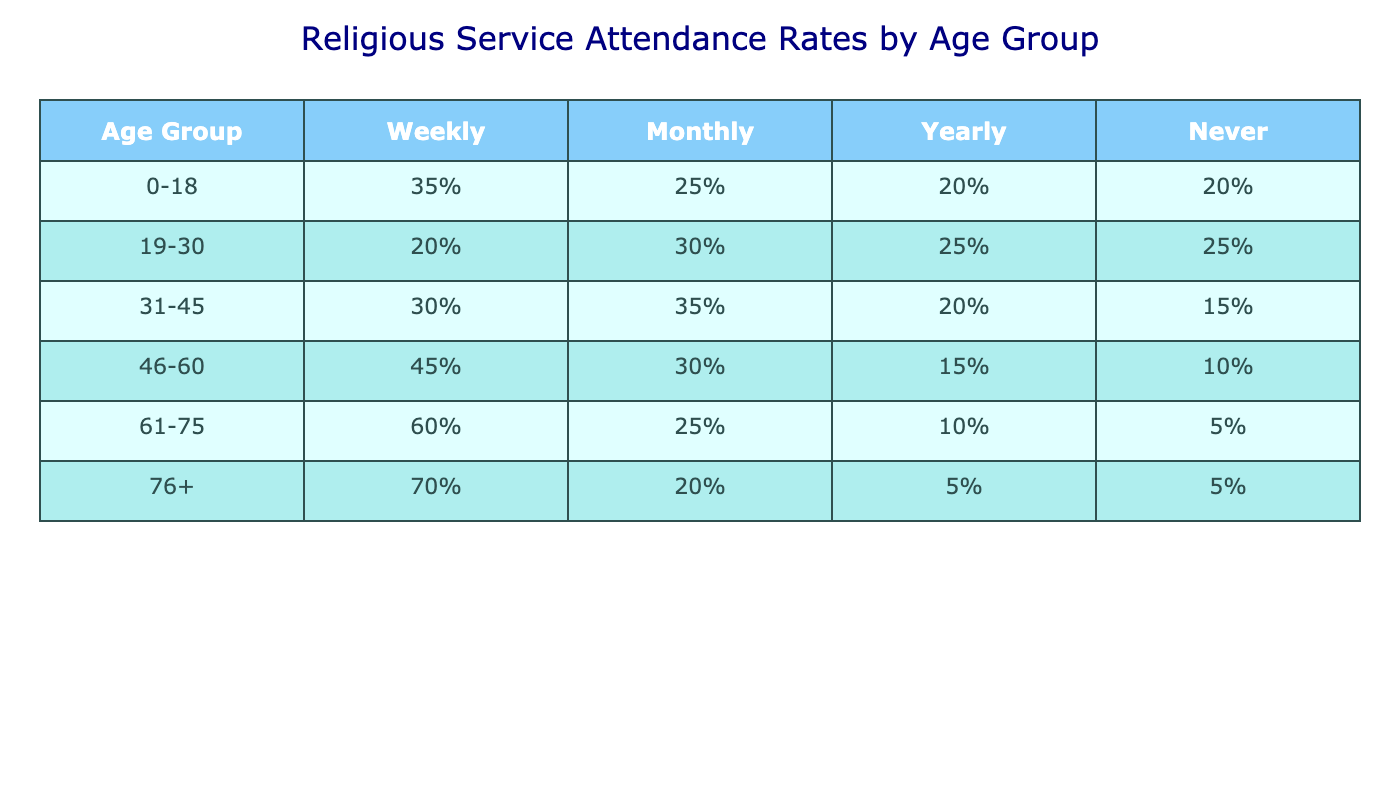What percentage of the 61-75 age group attends religious services weekly? The table shows that 60% of the 61-75 age group attends religious services weekly.
Answer: 60% Which age group has the lowest percentage of attendees who go to religious services yearly? The 76+ age group has the lowest yearly attendance at 5%.
Answer: 5% What is the combined percentage of the 46-60 age group that attends religious services at least monthly? The 46-60 age group has 45% attending weekly and 30% attending monthly, so the combined percentage is 45% + 30% = 75%.
Answer: 75% Does the percentage of individuals in the 0-18 age group who never attend religious services exceed 20%? No, the percentage of individuals in the 0-18 age group who never attend religious services is exactly 20%.
Answer: No Which age group has a higher percentage of weekly attendees: 31-45 or 46-60? The 46-60 age group has 45% attendance while the 31-45 age group has 30%, so 46-60 has a higher percentage.
Answer: 46-60 What is the average percentage of 'Never' attendees across all age groups? To find the average, add the 'Never' percentages (20 + 25 + 15 + 10 + 5 + 5) = 80%. Since there are 6 groups, divide by 6: 80% / 6 = approximately 13.33%.
Answer: 13.33% How much more likely are individuals aged 76+ to attend weekly compared to those aged 19-30? Individuals aged 76+ attend weekly at a rate of 70% while those aged 19-30 attend at 20%, so the difference is 70% - 20% = 50%.
Answer: 50% Which age group has the highest rate of monthly attendance? The 31-45 age group has the highest rate of monthly attendance at 35%.
Answer: 31-45 Is the percentage of the 46-60 age group attending yearly services greater than 15%? Yes, the 46-60 age group has a yearly attendance rate of 15%.
Answer: Yes What is the difference in the percentage of those who attend weekly between the youngest age group (0-18) and the oldest age group (76+)? The 0-18 age group has a weekly attendance of 35% while the 76+ age group has 70%, so the difference is 70% - 35% = 35%.
Answer: 35% 